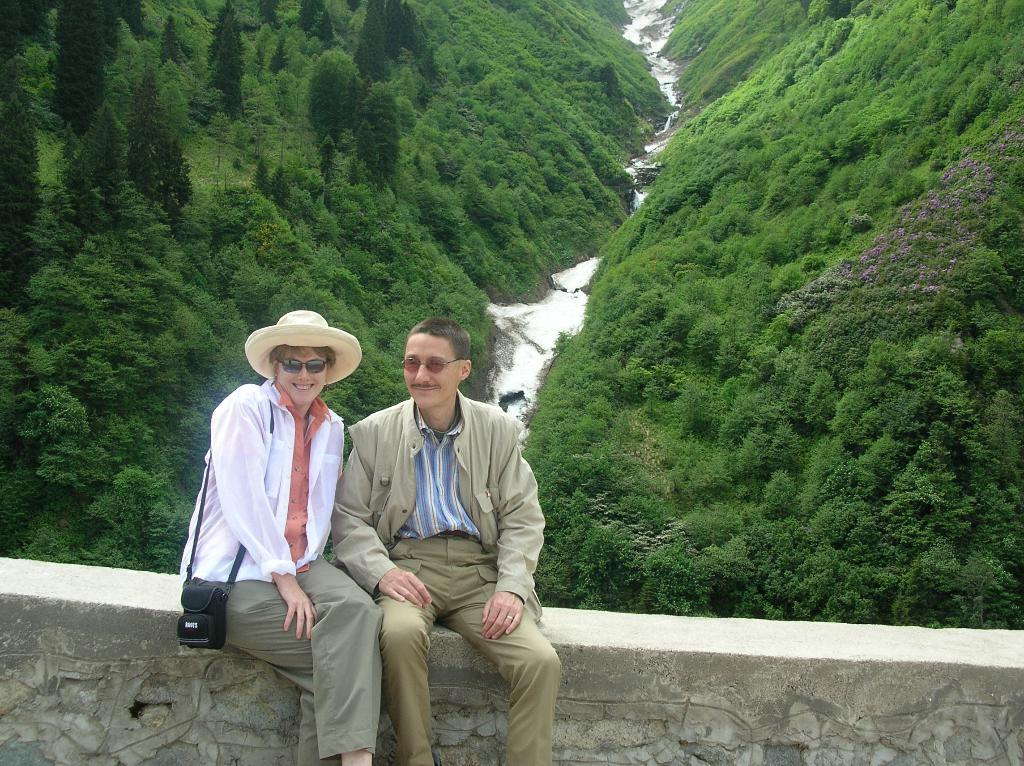How many people are in the image? There are two persons in the image. What is one of the persons wearing? One of the persons is wearing a hat. What object can be seen in the image that is commonly used for capturing images? There is a camera in the image. What type of natural environment is visible in the image? There are trees and a river in the image. What is the cause of the loss experienced by the crowd in the image? There is no crowd present in the image, and therefore no loss can be attributed to them. 